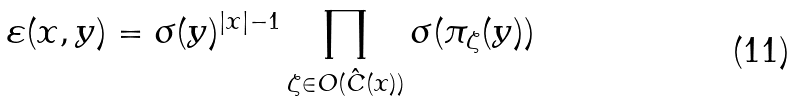Convert formula to latex. <formula><loc_0><loc_0><loc_500><loc_500>\varepsilon ( x , y ) = \sigma ( y ) ^ { | x | - 1 } \prod _ { \zeta \in O ( \hat { C } ( x ) ) } \sigma ( \pi _ { \zeta } ( y ) )</formula> 